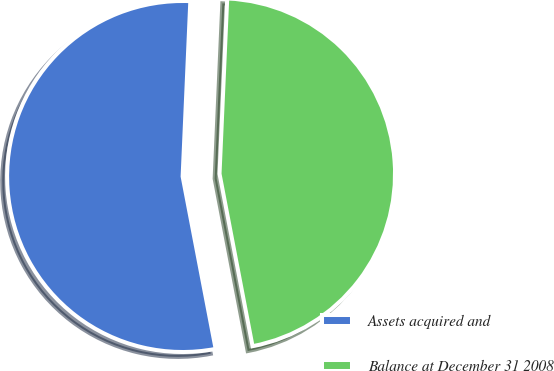Convert chart. <chart><loc_0><loc_0><loc_500><loc_500><pie_chart><fcel>Assets acquired and<fcel>Balance at December 31 2008<nl><fcel>53.71%<fcel>46.29%<nl></chart> 